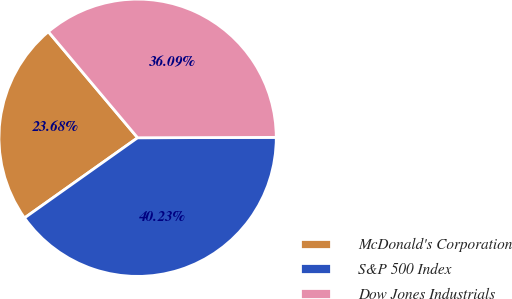Convert chart. <chart><loc_0><loc_0><loc_500><loc_500><pie_chart><fcel>McDonald's Corporation<fcel>S&P 500 Index<fcel>Dow Jones Industrials<nl><fcel>23.68%<fcel>40.23%<fcel>36.09%<nl></chart> 